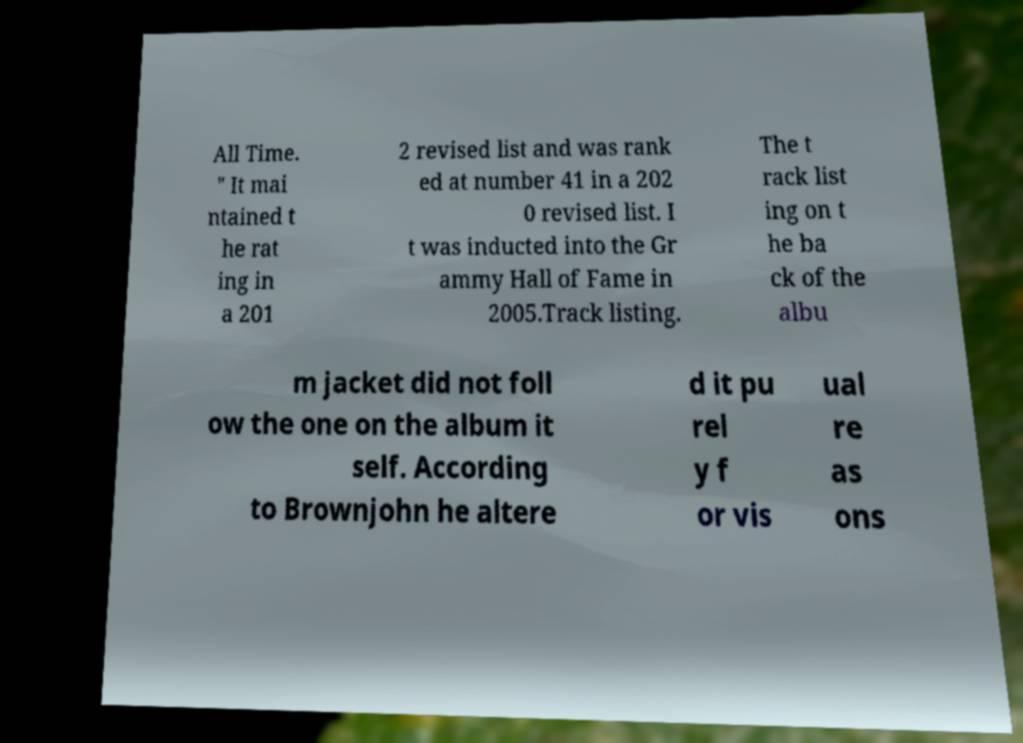Please read and relay the text visible in this image. What does it say? All Time. " It mai ntained t he rat ing in a 201 2 revised list and was rank ed at number 41 in a 202 0 revised list. I t was inducted into the Gr ammy Hall of Fame in 2005.Track listing. The t rack list ing on t he ba ck of the albu m jacket did not foll ow the one on the album it self. According to Brownjohn he altere d it pu rel y f or vis ual re as ons 